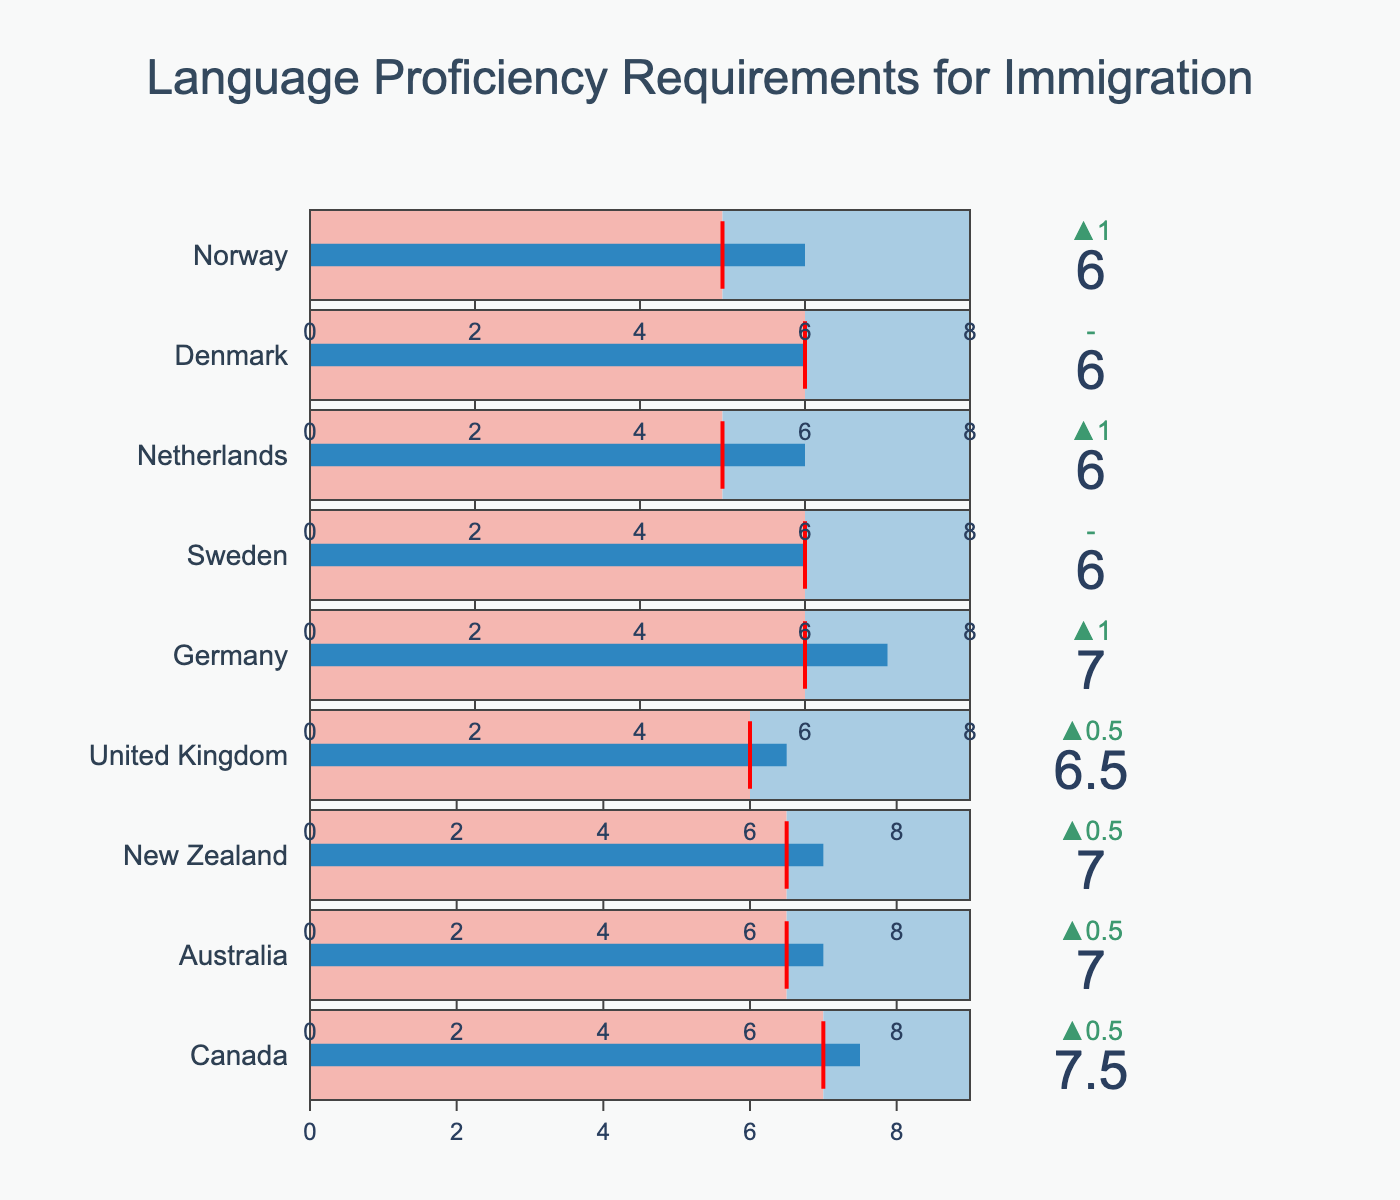How many countries have C2 as their maximum language proficiency score? First, identify the maximum scores for each country, which are all listed as 'C2' for Germany, Sweden, Netherlands, Denmark, and Norway. Therefore, count these countries.
Answer: 5 Which country has the highest required language proficiency score? Compare the required scores for all countries. The highest score in the list is for Germany with B2, which is higher than other numeric values.
Answer: Germany What is the difference between the required score and the average score for Canada? For Canada, the required score is 7, and the average score is 7.5. Subtract these values: 7.5 - 7 = 0.5.
Answer: 0.5 Which country has the smallest difference between the required score and the average score? Compare the differences between the required and average scores for all countries. Canada's difference is 0.5, Nigeria's is 0.5 which is less or equal among others.
Answer: Canada, Australia & New Zealand* How does the Netherlands' language proficiency requirements compare to Sweden's? The Netherlands requires B1 and Sweden requires B2. Sweden requires a higher level (B2 > B1).
Answer: Sweden Which countries have a required score lower than 7? By searching the "Required Score" column, we find that Australia (6.5), New Zealand (6.5), United Kingdom (6), Germany (B2), Sweden (B2), Netherlands (B1), Denmark (B2), and Norway (B1) have scores lower than 7.
Answer: Australia, New Zealand, United Kingdom, Germany, Sweden, Netherlands, Denmark, Norway Which country has the average score closest to its maximum score? Compare the average scores to maximum scores; for Canada (7.5/9), Australia (7/9), New Zealand (7/9), United Kingdom (6.5/9), Germany (C1/C2), Sweden (B2/C2), Netherlands (B2/C2), Denmark (B2/C2), and Norway (B2/C2). Calculate the differences to find the smallest one. Canada's difference is the smallest (7.5 to 9).
Answer: Canada If a move is based purely on meeting the minimum language criteria, which countries might be easier options? Compare the "Required Score" for each country. The ones with the lowest scores (B1 for Netherlands and Norway) would be considered easier options.
Answer: Netherlands, Norway 